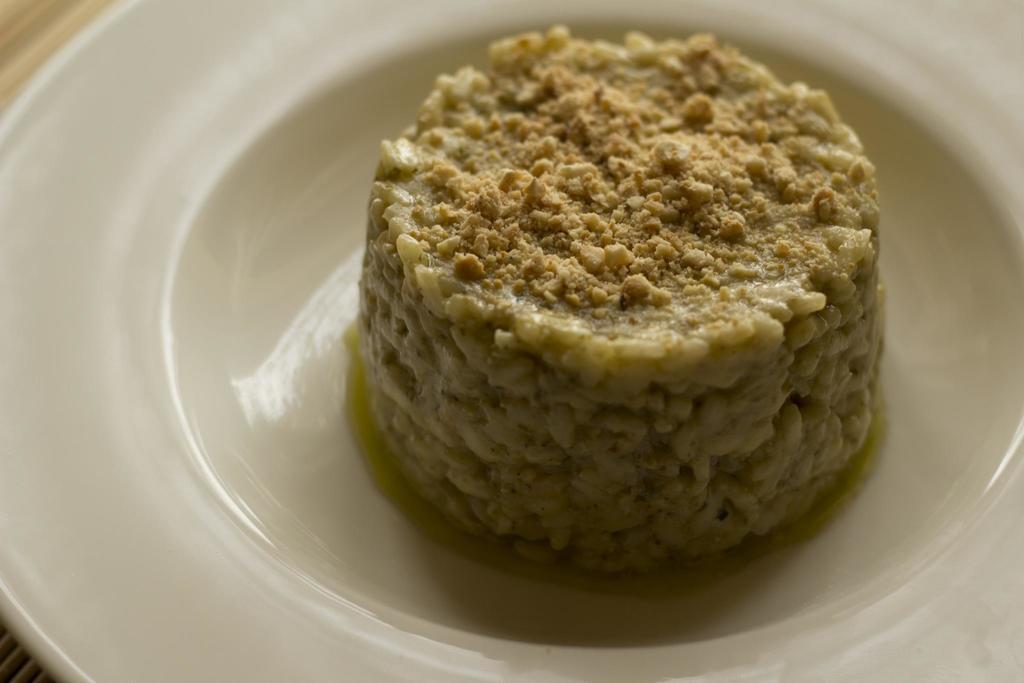Could you give a brief overview of what you see in this image? In the foreground of this image, there is food item on a platter. 